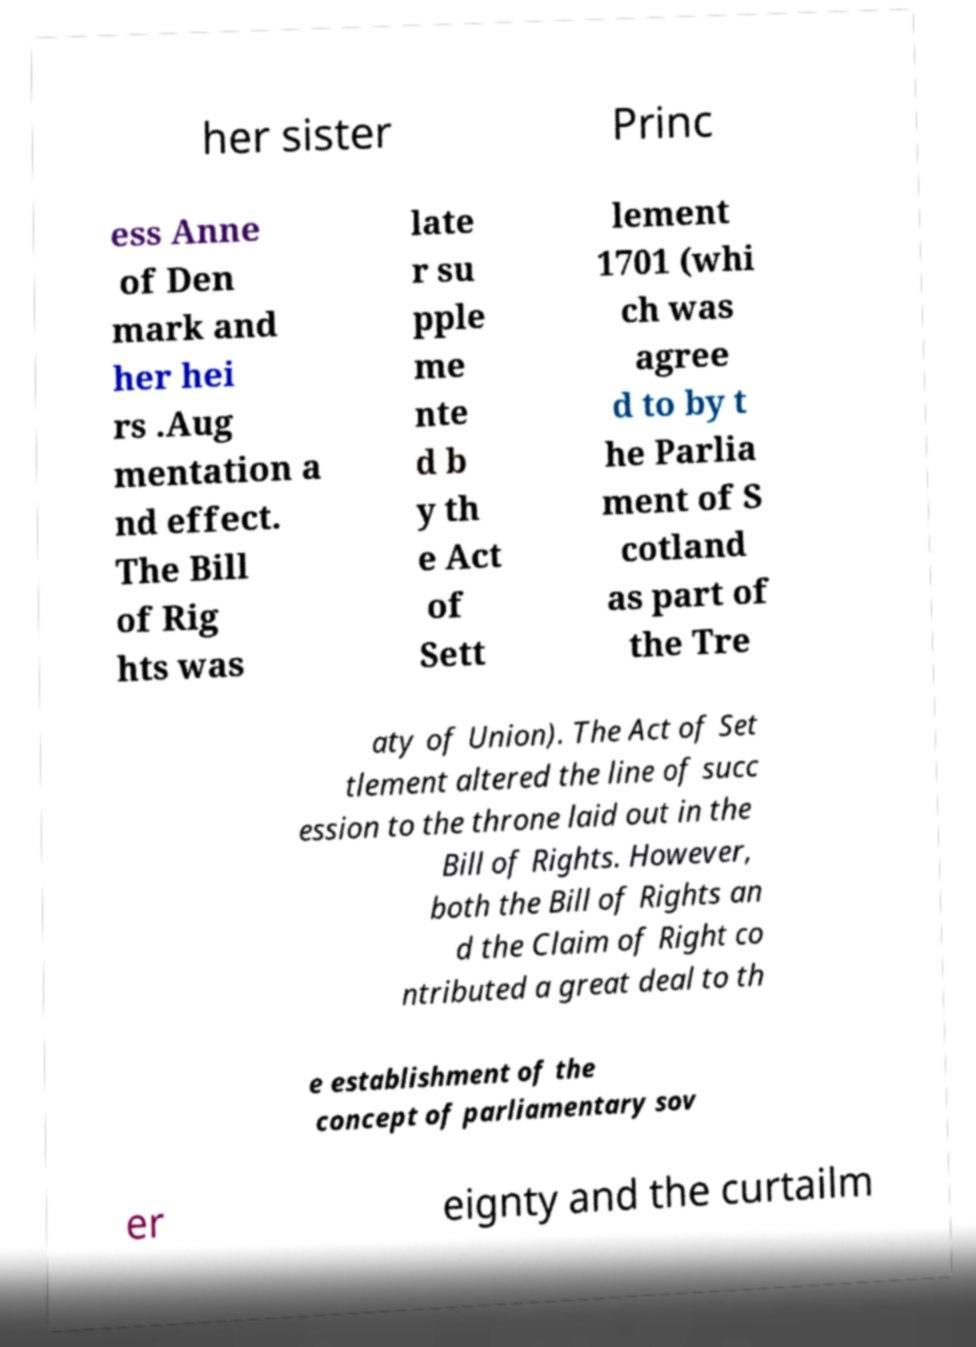Can you accurately transcribe the text from the provided image for me? her sister Princ ess Anne of Den mark and her hei rs .Aug mentation a nd effect. The Bill of Rig hts was late r su pple me nte d b y th e Act of Sett lement 1701 (whi ch was agree d to by t he Parlia ment of S cotland as part of the Tre aty of Union). The Act of Set tlement altered the line of succ ession to the throne laid out in the Bill of Rights. However, both the Bill of Rights an d the Claim of Right co ntributed a great deal to th e establishment of the concept of parliamentary sov er eignty and the curtailm 